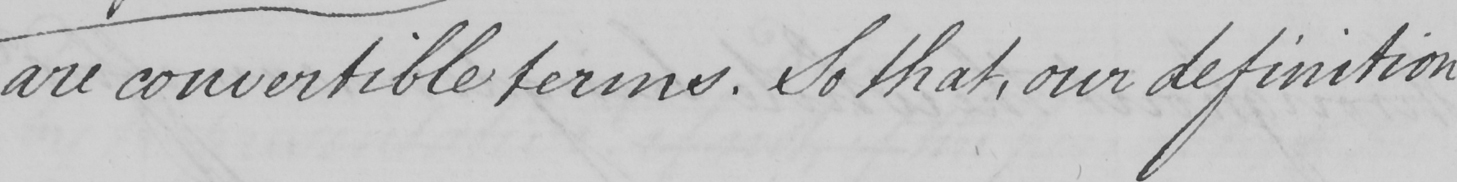Can you read and transcribe this handwriting? are convertible terms. So that, our definition 